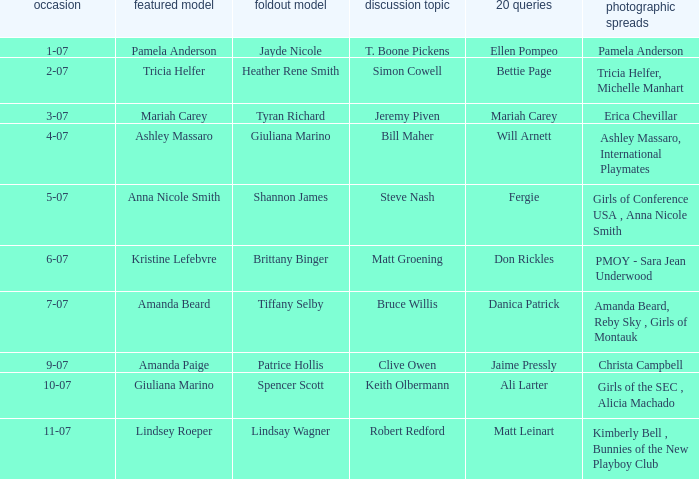Who replied to the 20 queries on 10-07? Ali Larter. 